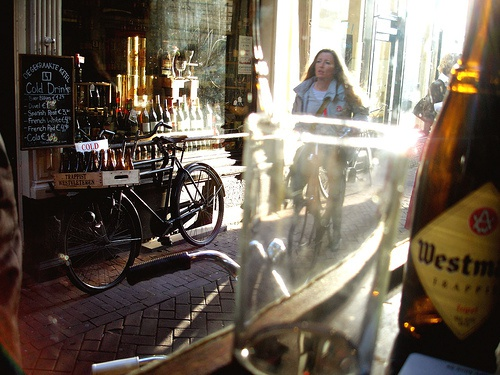Describe the objects in this image and their specific colors. I can see cup in black, ivory, darkgray, and gray tones, bottle in black, maroon, and olive tones, bicycle in black, white, gray, and maroon tones, people in black, gray, and darkgray tones, and bicycle in black, gray, and darkgray tones in this image. 